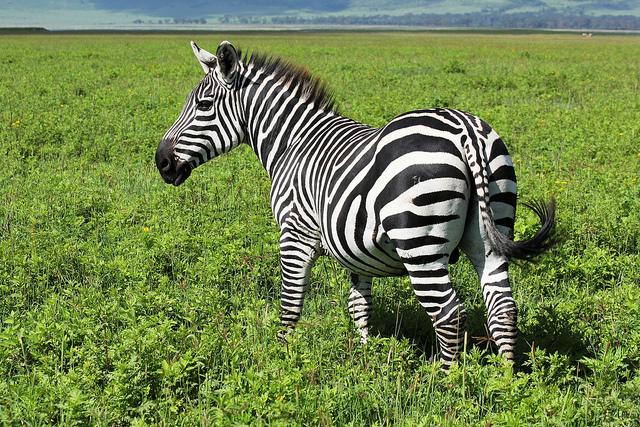What animal is this?
Be succinct. Zebra. Is the zebra a boy?
Concise answer only. Yes. What is the zebra standing in?
Be succinct. Grass. Where is the green color?
Short answer required. Grass. 